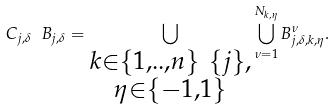<formula> <loc_0><loc_0><loc_500><loc_500>C _ { j , \delta } \ B _ { j , \delta } = \bigcup _ { \substack { k \in \{ 1 , . . , n \} \ \{ j \} , \\ \eta \in \{ - 1 , 1 \} } } \bigcup _ { \nu = 1 } ^ { N _ { k , \eta } } B _ { j , \delta , k , \eta } ^ { \nu } .</formula> 